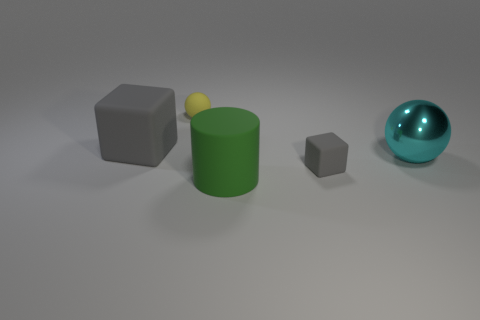Are there any other things that are the same shape as the big green rubber thing?
Provide a succinct answer. No. Is the number of green rubber cubes greater than the number of small yellow spheres?
Provide a short and direct response. No. Are there any large things of the same color as the large rubber block?
Offer a very short reply. No. There is a gray rubber block behind the cyan shiny sphere; is its size the same as the small rubber block?
Offer a terse response. No. Are there fewer blue matte objects than large rubber cylinders?
Ensure brevity in your answer.  Yes. Is there a brown block made of the same material as the cyan ball?
Offer a terse response. No. What shape is the gray thing on the right side of the small yellow matte sphere?
Provide a short and direct response. Cube. Do the large object that is in front of the metal sphere and the metal ball have the same color?
Ensure brevity in your answer.  No. Are there fewer tiny rubber things behind the small gray rubber block than tiny red objects?
Offer a very short reply. No. There is another tiny object that is the same material as the yellow thing; what color is it?
Your answer should be compact. Gray. 